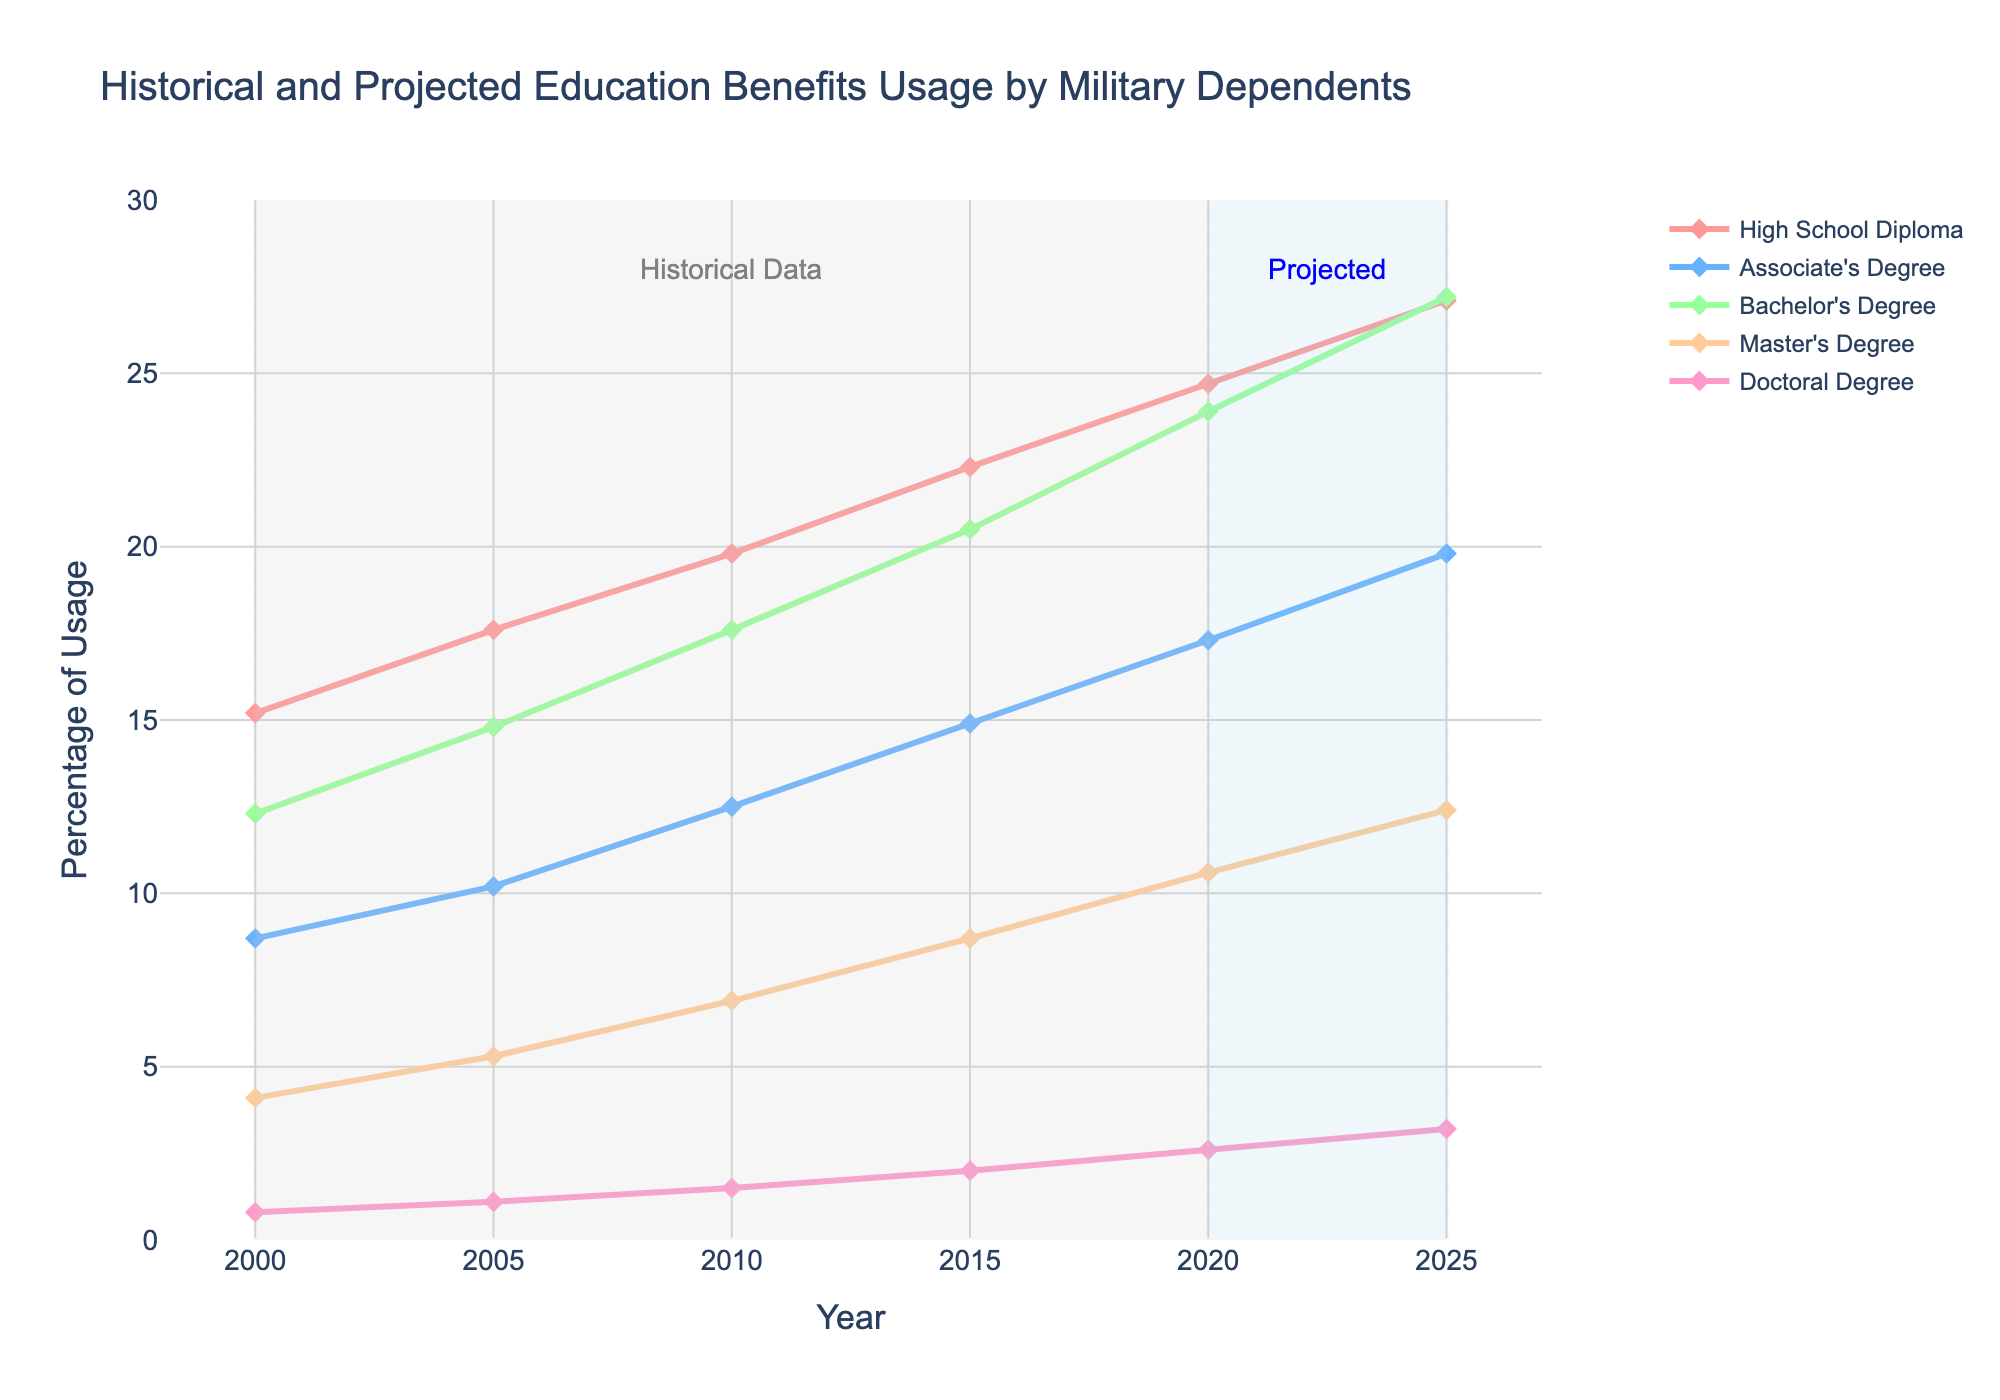What is the trend in Bachelor's Degree benefits usage from 2000 to 2025? The usage of Bachelor's Degree benefits shows a consistent increase over time. Starting at 12.3% in 2000 and rising steadily to 27.2% by 2025.
Answer: Consistent increase Which degree level had the highest benefits usage in 2025? In 2025, the degree level with the highest benefits usage is the High School Diploma with 27.1%. This is visually identified by the highest data point on the chart.
Answer: High School Diploma How does the projected growth from 2020 to 2025 for Master's Degree compare to that of Associate's Degree? To calculate the growth: Master's Degree grows from 10.6% to 12.4%, an increase of 1.8%. Associate's Degree grows from 17.3% to 19.8%, an increase of 2.5%. Comparing these, Associate's Degree has a higher projected growth.
Answer: Associate's Degree has higher growth Which degree level has the least growth from 2000 to 2025? By examining the data points visually, High School Diploma grows from 15.2% to 27.1%, Associate's Degree from 8.7% to 19.8%, Bachelor's Degree from 12.3% to 27.2%, Master's Degree from 4.1% to 12.4%, and Doctoral Degree from 0.8% to 3.2%. The least growth is seen in the Doctoral Degree (0.8% to 3.2%).
Answer: Doctoral Degree What is the percentage increase in Bachelor's Degree benefits usage from 2000 to 2010? The Bachelor's Degree usage increases from 12.3% in 2000 to 17.6% in 2010. The percentage increase is calculated as ((17.6 - 12.3) / 12.3) * 100 = 43.1%.
Answer: 43.1% Which section shows projected data, and what visual cues indicate this? The projected data is shown from the year 2020 to 2025. This is indicated by a light blue rectangular shape and a "Projected" annotation in blue text.
Answer: 2020 to 2025 Is the increase in Associate's Degree benefits usage between any two consecutive periods always greater than or equal to 2%? The increases are as follows: 2000 to 2005 (8.7% to 10.2%, increase of 1.5%), 2005 to 2010 (10.2% to 12.5%, increase of 2.3%), 2010 to 2015 (12.5% to 14.9%, increase of 2.4%), 2015 to 2020 (14.9% to 17.3%, increase of 2.4%), 2020 to 2025 (17.3% to 19.8%, increase of 2.5%). Thus, the increase from 2000 to 2005 is less than 2%.
Answer: No In 2020, which degree had nearly half the percentage usage as the Bachelor's Degree? In 2020, Bachelor's Degree usage is 23.9%. Half of this is approximately 12%. The Master's Degree has a usage of 10.6%, which is closest.
Answer: Master's Degree As of 2015, which two degree levels have seen the most similar total percentage increases since 2000? From 2000 to 2015: High School Diploma increased 7.1% (22.3% - 15.2%), and Bachelor's Degree increased 8.2% (20.5% - 12.3%). Master's Degree increased 4.6% (8.7% - 4.1%), and Doctoral Degree increased 1.2% (2.0% - 0.8%). High School Diploma and Bachelor's Degree have similar increases.
Answer: High School Diploma and Bachelor's Degree 